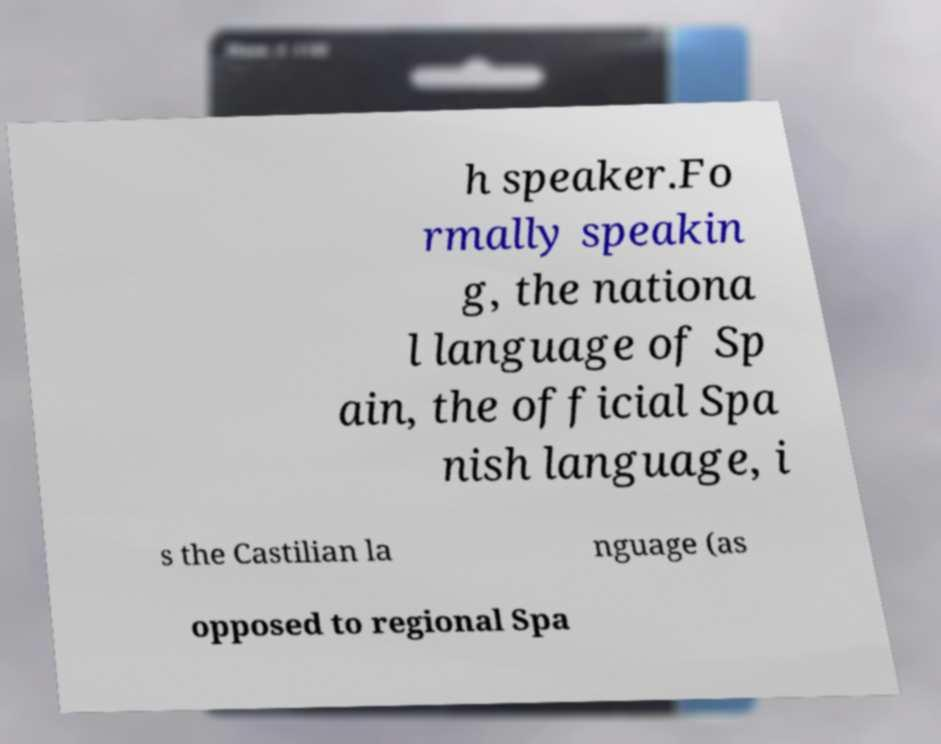Could you assist in decoding the text presented in this image and type it out clearly? h speaker.Fo rmally speakin g, the nationa l language of Sp ain, the official Spa nish language, i s the Castilian la nguage (as opposed to regional Spa 